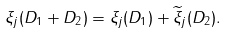Convert formula to latex. <formula><loc_0><loc_0><loc_500><loc_500>\xi _ { j } ( D _ { 1 } + D _ { 2 } ) = \xi _ { j } ( D _ { 1 } ) + \widetilde { \xi } _ { j } ( D _ { 2 } ) .</formula> 